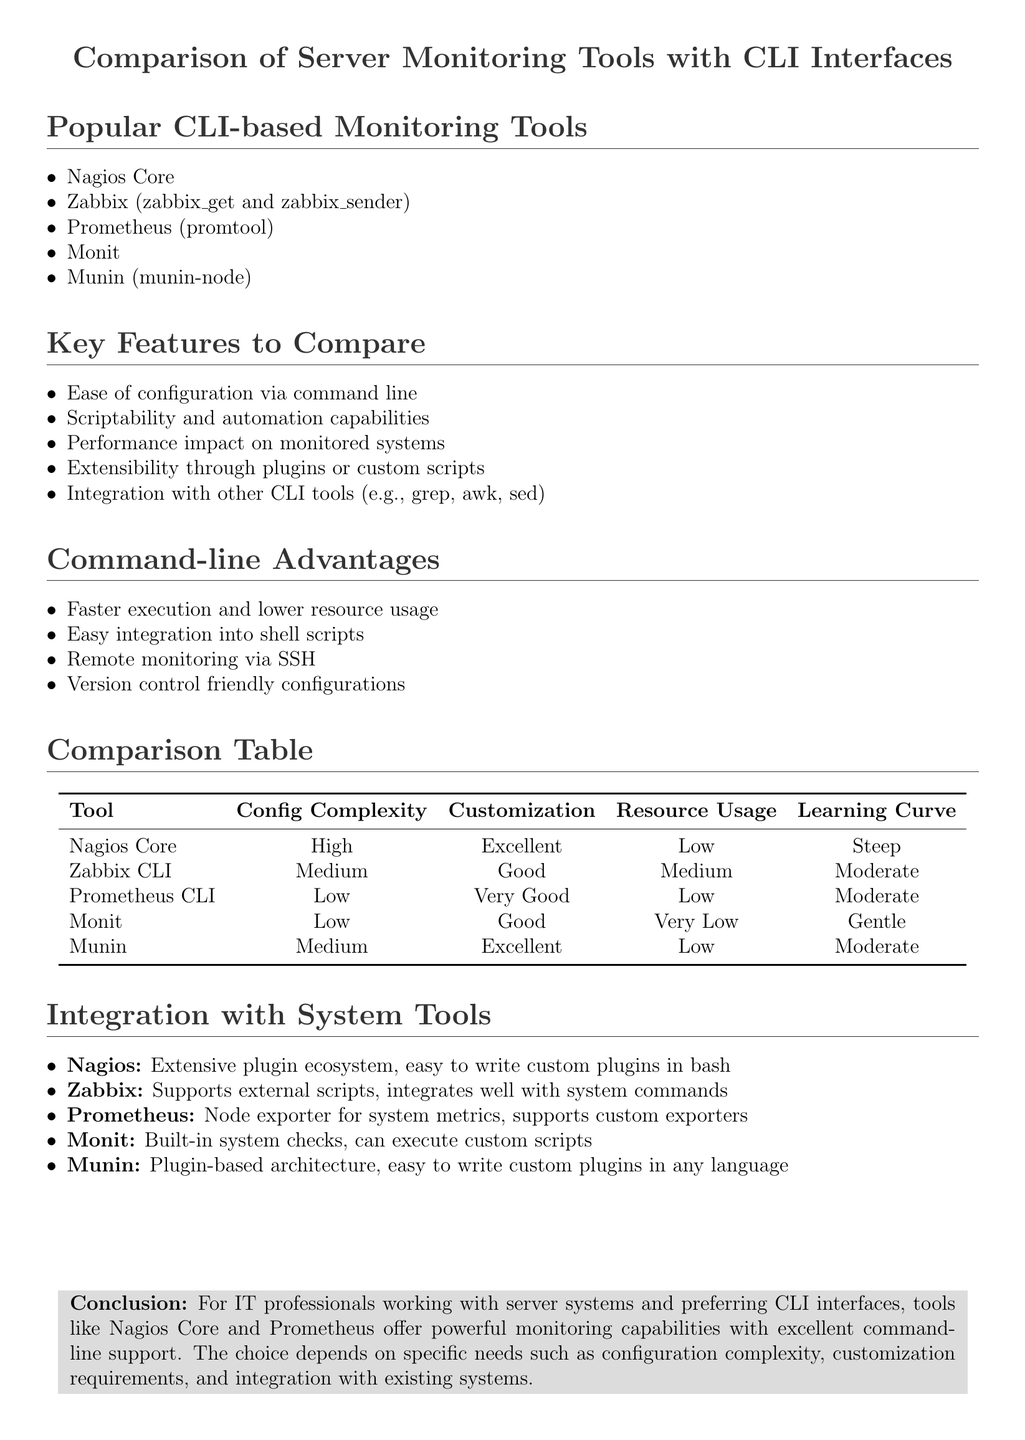What are the popular CLI-based monitoring tools? The document lists popular CLI-based monitoring tools under a specific section.
Answer: Nagios Core, Zabbix, Prometheus, Monit, Munin What is the configuration complexity of Prometheus CLI? The comparison table provides the configuration complexity for each tool.
Answer: Low Which tool has the steepest learning curve? The learning curve column in the comparison table indicates the difficulty of each tool.
Answer: Nagios Core What are the command-line advantages mentioned? The document outlines several benefits of using command-line tools in a dedicated section.
Answer: Faster execution, easy integration, remote monitoring, version control friendly Which monitoring tool offers very low resource usage? Resource usage is specified in the comparison table for each tool.
Answer: Monit Which tool has excellent customization according to the document? The customization column in the comparison table reveals this information.
Answer: Nagios Core, Munin How does Nagios integrate with system tools? The document describes the integration capabilities of Nagios in a specific section.
Answer: Extensive plugin ecosystem What conclusion does the document draw about monitoring tools? The conclusion summarizes the overall finding related to CLI tool capabilities.
Answer: Tools like Nagios Core and Prometheus offer powerful monitoring capabilities with excellent command-line support 